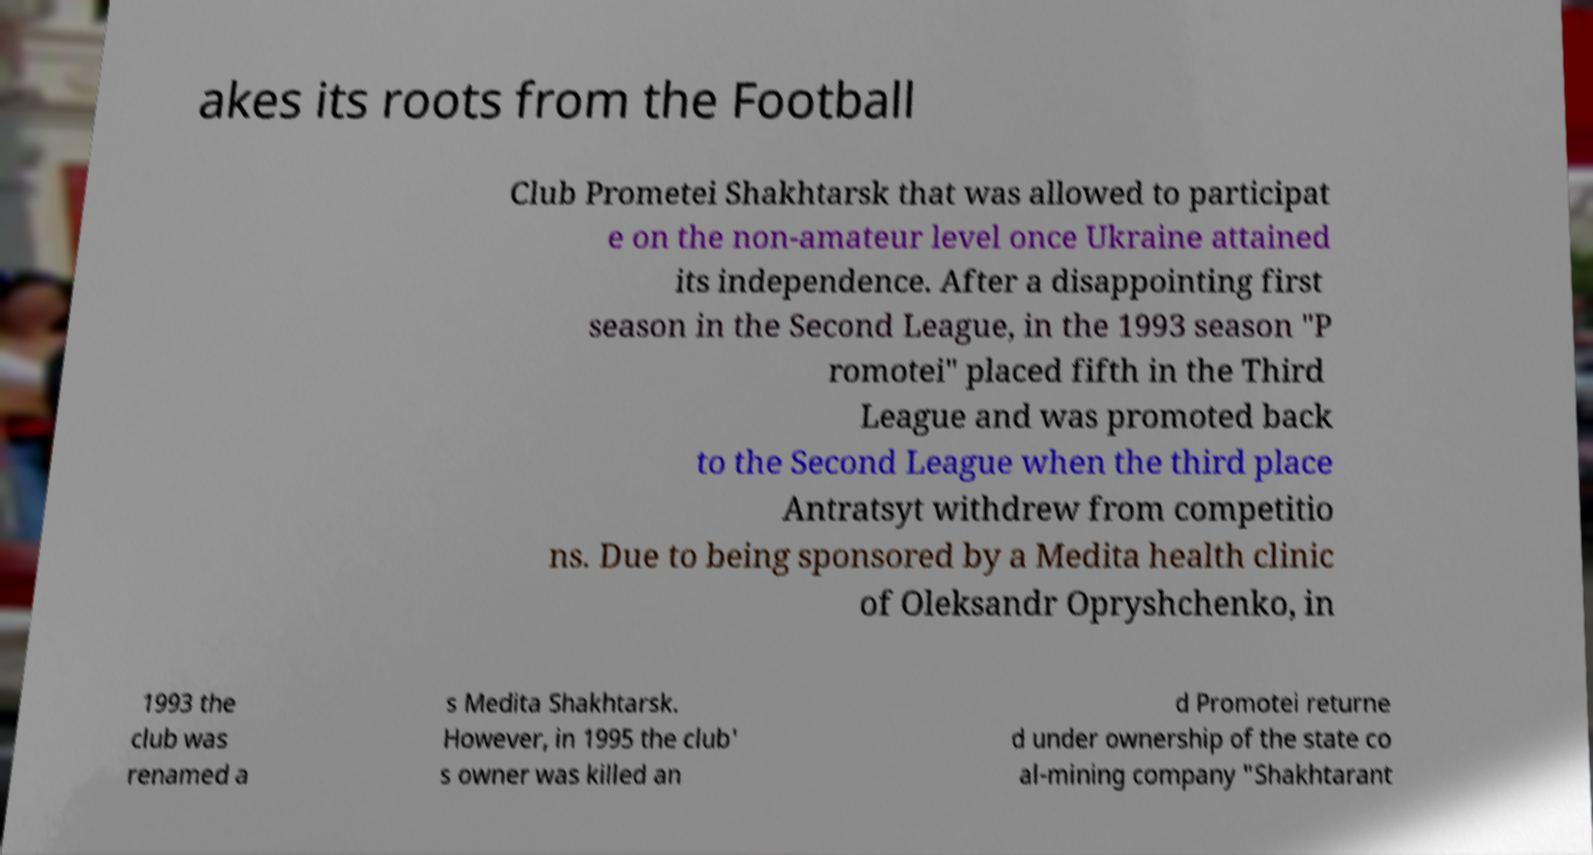Please read and relay the text visible in this image. What does it say? akes its roots from the Football Club Prometei Shakhtarsk that was allowed to participat e on the non-amateur level once Ukraine attained its independence. After a disappointing first season in the Second League, in the 1993 season "P romotei" placed fifth in the Third League and was promoted back to the Second League when the third place Antratsyt withdrew from competitio ns. Due to being sponsored by a Medita health clinic of Oleksandr Opryshchenko, in 1993 the club was renamed a s Medita Shakhtarsk. However, in 1995 the club' s owner was killed an d Promotei returne d under ownership of the state co al-mining company "Shakhtarant 